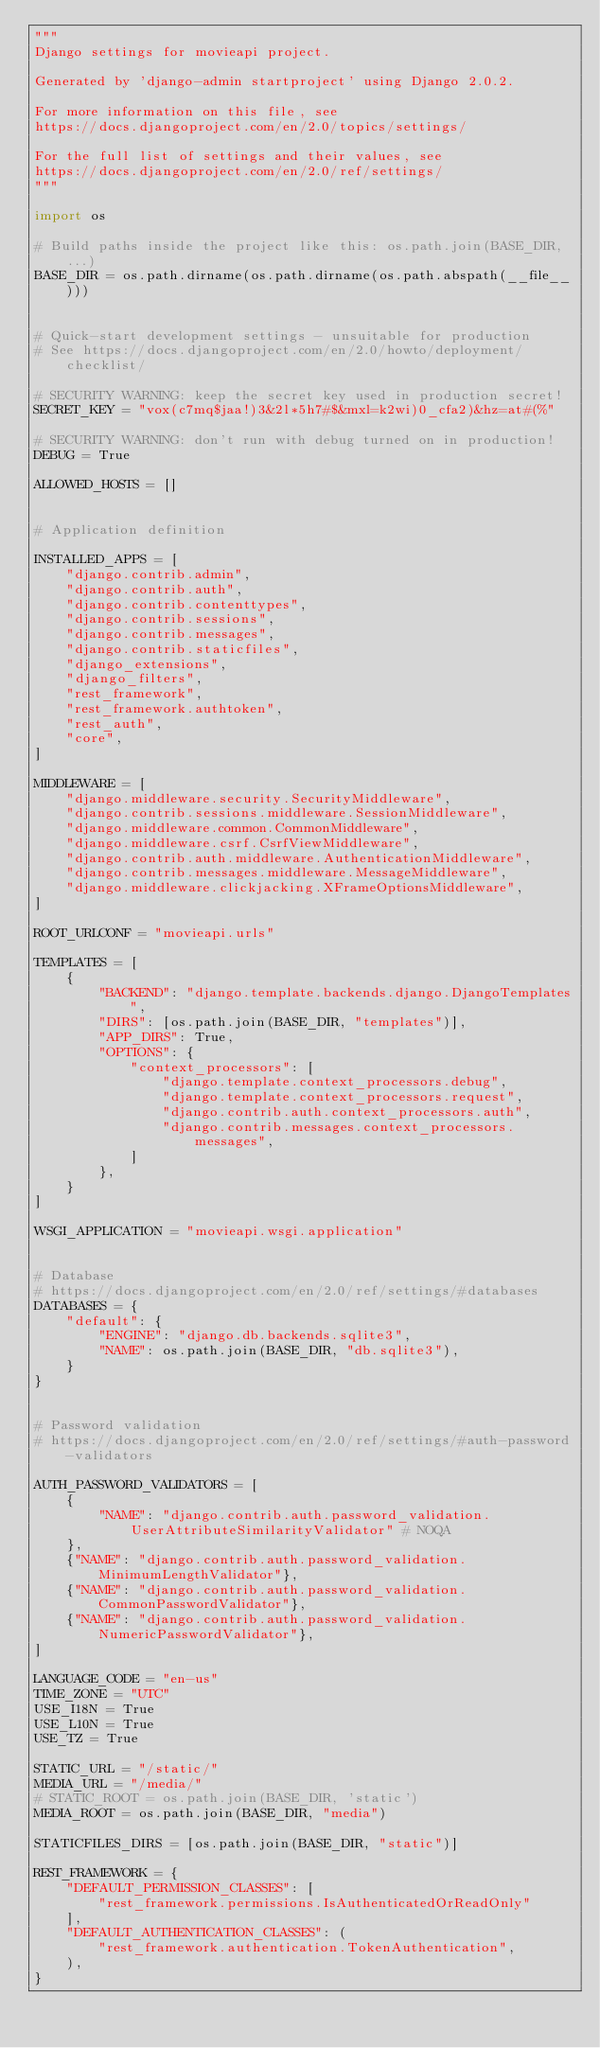<code> <loc_0><loc_0><loc_500><loc_500><_Python_>"""
Django settings for movieapi project.

Generated by 'django-admin startproject' using Django 2.0.2.

For more information on this file, see
https://docs.djangoproject.com/en/2.0/topics/settings/

For the full list of settings and their values, see
https://docs.djangoproject.com/en/2.0/ref/settings/
"""

import os

# Build paths inside the project like this: os.path.join(BASE_DIR, ...)
BASE_DIR = os.path.dirname(os.path.dirname(os.path.abspath(__file__)))


# Quick-start development settings - unsuitable for production
# See https://docs.djangoproject.com/en/2.0/howto/deployment/checklist/

# SECURITY WARNING: keep the secret key used in production secret!
SECRET_KEY = "vox(c7mq$jaa!)3&2l*5h7#$&mxl=k2wi)0_cfa2)&hz=at#(%"

# SECURITY WARNING: don't run with debug turned on in production!
DEBUG = True

ALLOWED_HOSTS = []


# Application definition

INSTALLED_APPS = [
    "django.contrib.admin",
    "django.contrib.auth",
    "django.contrib.contenttypes",
    "django.contrib.sessions",
    "django.contrib.messages",
    "django.contrib.staticfiles",
    "django_extensions",
    "django_filters",
    "rest_framework",
    "rest_framework.authtoken",
    "rest_auth",
    "core",
]

MIDDLEWARE = [
    "django.middleware.security.SecurityMiddleware",
    "django.contrib.sessions.middleware.SessionMiddleware",
    "django.middleware.common.CommonMiddleware",
    "django.middleware.csrf.CsrfViewMiddleware",
    "django.contrib.auth.middleware.AuthenticationMiddleware",
    "django.contrib.messages.middleware.MessageMiddleware",
    "django.middleware.clickjacking.XFrameOptionsMiddleware",
]

ROOT_URLCONF = "movieapi.urls"

TEMPLATES = [
    {
        "BACKEND": "django.template.backends.django.DjangoTemplates",
        "DIRS": [os.path.join(BASE_DIR, "templates")],
        "APP_DIRS": True,
        "OPTIONS": {
            "context_processors": [
                "django.template.context_processors.debug",
                "django.template.context_processors.request",
                "django.contrib.auth.context_processors.auth",
                "django.contrib.messages.context_processors.messages",
            ]
        },
    }
]

WSGI_APPLICATION = "movieapi.wsgi.application"


# Database
# https://docs.djangoproject.com/en/2.0/ref/settings/#databases
DATABASES = {
    "default": {
        "ENGINE": "django.db.backends.sqlite3",
        "NAME": os.path.join(BASE_DIR, "db.sqlite3"),
    }
}


# Password validation
# https://docs.djangoproject.com/en/2.0/ref/settings/#auth-password-validators

AUTH_PASSWORD_VALIDATORS = [
    {
        "NAME": "django.contrib.auth.password_validation.UserAttributeSimilarityValidator" # NOQA
    },
    {"NAME": "django.contrib.auth.password_validation.MinimumLengthValidator"},
    {"NAME": "django.contrib.auth.password_validation.CommonPasswordValidator"},
    {"NAME": "django.contrib.auth.password_validation.NumericPasswordValidator"},
]

LANGUAGE_CODE = "en-us"
TIME_ZONE = "UTC"
USE_I18N = True
USE_L10N = True
USE_TZ = True

STATIC_URL = "/static/"
MEDIA_URL = "/media/"
# STATIC_ROOT = os.path.join(BASE_DIR, 'static')
MEDIA_ROOT = os.path.join(BASE_DIR, "media")

STATICFILES_DIRS = [os.path.join(BASE_DIR, "static")]

REST_FRAMEWORK = {
    "DEFAULT_PERMISSION_CLASSES": [
        "rest_framework.permissions.IsAuthenticatedOrReadOnly"
    ],
    "DEFAULT_AUTHENTICATION_CLASSES": (
        "rest_framework.authentication.TokenAuthentication",
    ),
}
</code> 